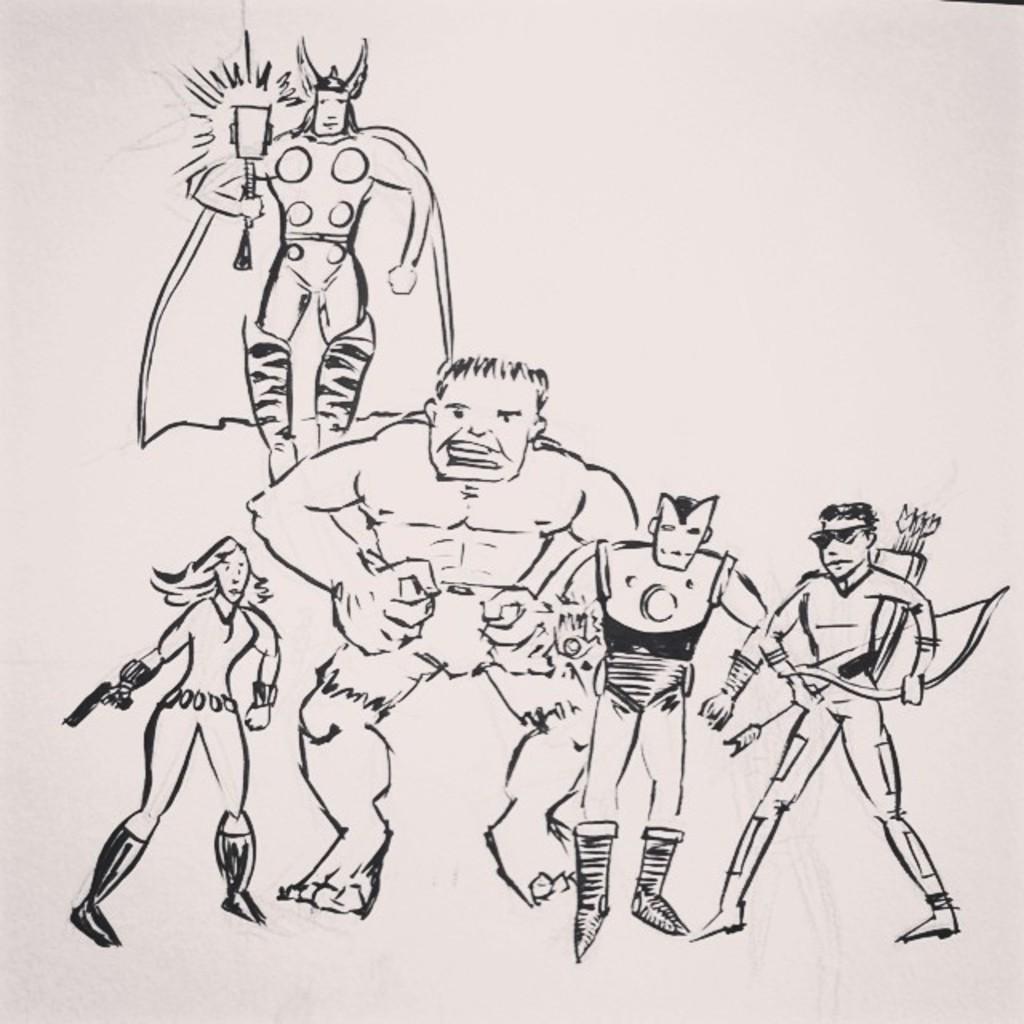In one or two sentences, can you explain what this image depicts? In the foreground of this picture we can see the drawing of group of persons seems to be standing. On the left there is a drawing of a woman holding a gun and seems to be standing. At the top there is a sketch of a person holding some object. The background of the image is white in color. 